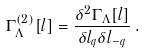<formula> <loc_0><loc_0><loc_500><loc_500>\Gamma _ { \Lambda } ^ { ( 2 ) } [ l ] = \frac { \delta ^ { 2 } \Gamma _ { \Lambda } [ l ] } { \delta l _ { q } \delta l _ { - q } } \, .</formula> 